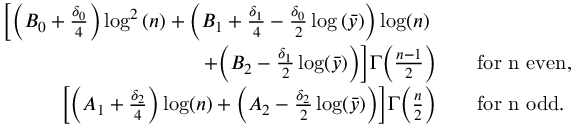<formula> <loc_0><loc_0><loc_500><loc_500>\begin{array} { r l } { \left [ \left ( B _ { 0 } + \frac { \delta _ { 0 } } { 4 } \right ) \log ^ { 2 } { ( n ) } + \left ( B _ { 1 } + \frac { \delta _ { 1 } } { 4 } - \frac { \delta _ { 0 } } { 2 } \log { ( \bar { y } ) } \right ) \log ( n ) \quad } \\ { + \left ( B _ { 2 } - \frac { \delta _ { 1 } } { 2 } \log ( \bar { y } ) \right ) \right ] \Gamma \left ( \frac { n - 1 } { 2 } \right ) \quad } & { f o r n e v e n , } \\ { \left [ \left ( A _ { 1 } + \frac { \delta _ { 2 } } { 4 } \right ) \log ( n ) + \left ( A _ { 2 } - \frac { \delta _ { 2 } } { 2 } \log ( \bar { y } ) \right ) \right ] \Gamma \left ( \frac { n } { 2 } \right ) \quad } & { f o r n o d d . } \end{array}</formula> 